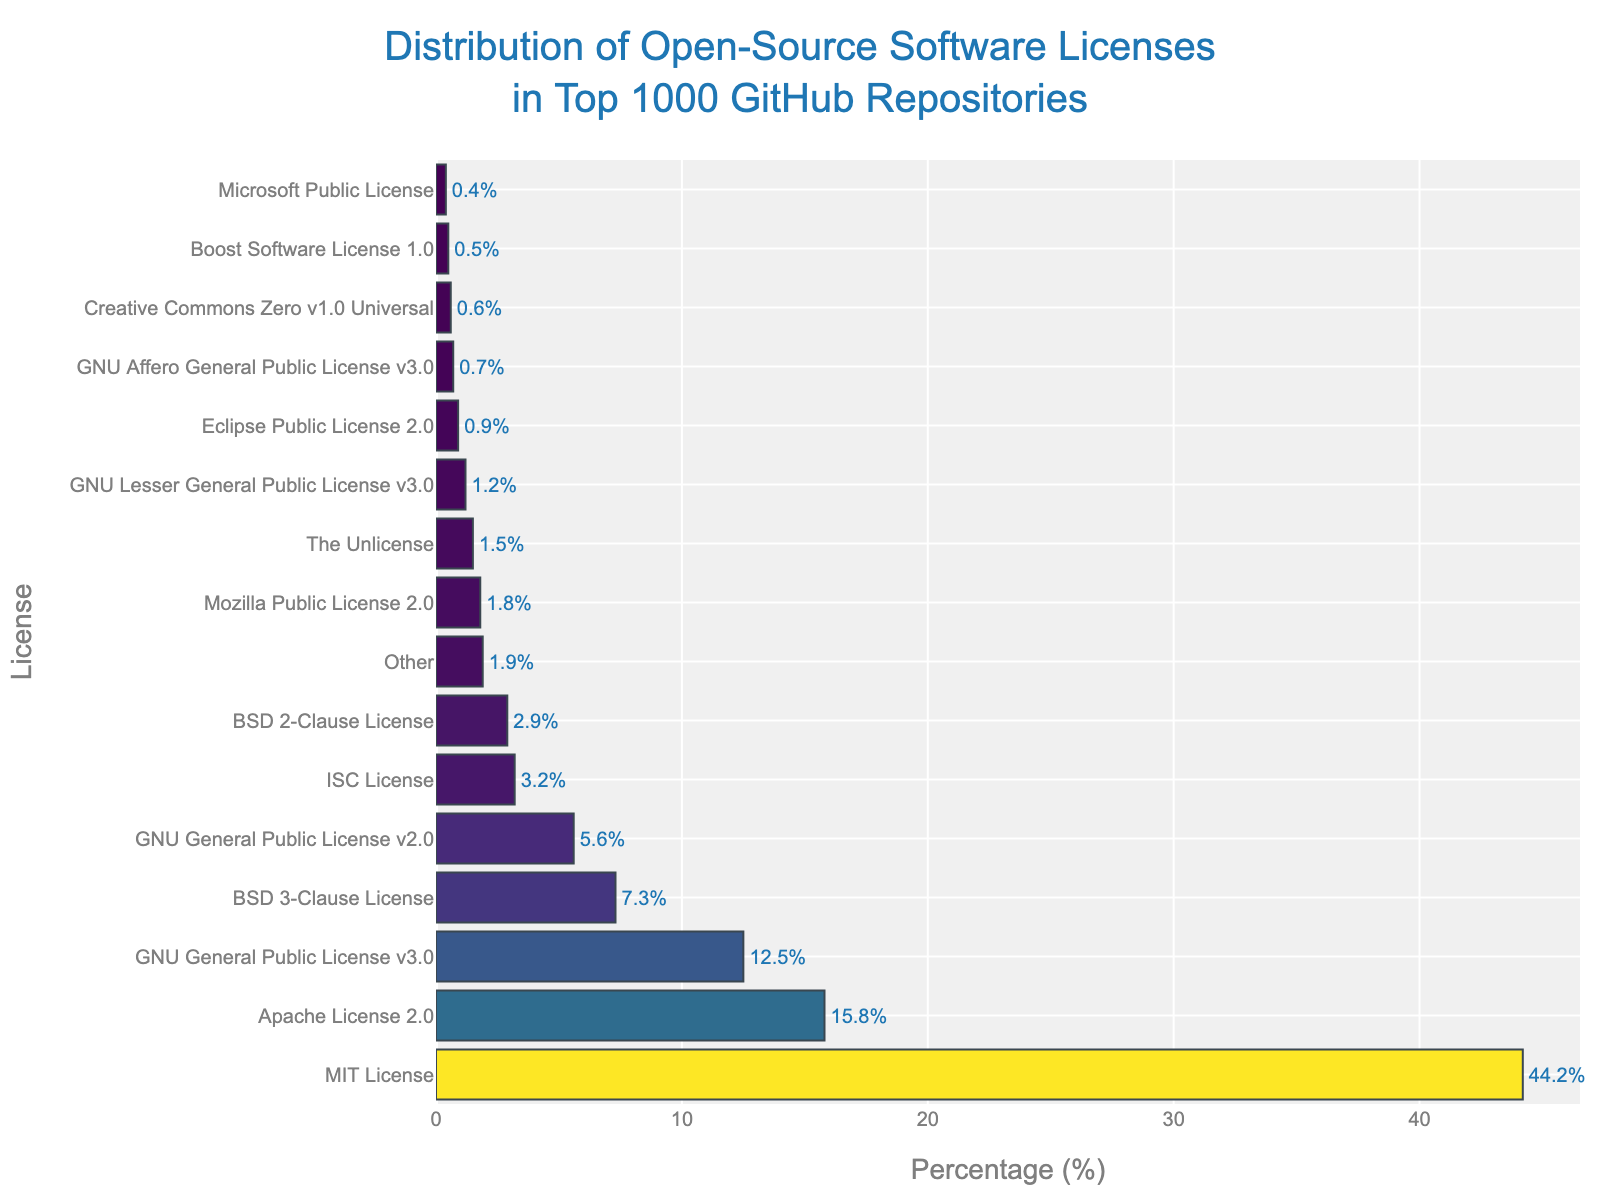What is the most commonly used license among the top 1000 GitHub repositories? The figure shows that the MIT License bar is the longest and positioned at the top, indicating it has the highest percentage at 44.2%.
Answer: MIT License How much higher is the percentage of MIT License compared to Apache License 2.0? The figure shows the MIT License at 44.2% and Apache License 2.0 at 15.8%. The difference is calculated as 44.2% - 15.8%.
Answer: 28.4% Which licenses have a usage percentage below 1%? The figure shows that the Eclipse Public License 2.0, GNU Affero General Public License v3.0, Creative Commons Zero v1.0 Universal, Boost Software License 1.0, and Microsoft Public License all have bars with percentages below 1%.
Answer: Eclipse Public License 2.0, GNU Affero General Public License v3.0, Creative Commons Zero v1.0 Universal, Boost Software License 1.0, Microsoft Public License How does the usage percentage of BSD 3-Clause License compare to GNU General Public License v2.0? The figure shows that BSD 3-Clause License has a percentage of 7.3%, while GNU General Public License v2.0 shows 5.6%. BSD 3-Clause License is higher.
Answer: BSD 3-Clause License is higher What is the combined percentage of all GNU licenses? Summing up the percentages of GNU licenses listed in the figure: GNU General Public License v3.0 (12.5%), GNU General Public License v2.0 (5.6%), GNU Lesser General Public License v3.0 (1.2%), and GNU Affero General Public License v3.0 (0.7%). Adding these yields 12.5% + 5.6% + 1.2% + 0.7%.
Answer: 20.0% What licenses are represented by bars colored with the darkest shade in the figure? The darkest shades are typically used for the lowest-value bars. The bars for the Eclipse Public License 2.0 (0.9%), GNU Affero General Public License v3.0 (0.7%), Creative Commons Zero v1.0 Universal (0.6%), Boost Software License 1.0 (0.5%), and Microsoft Public License (0.4%) show the darkest colors.
Answer: Eclipse Public License 2.0, GNU Affero General Public License v3.0, Creative Commons Zero v1.0 Universal, Boost Software License 1.0, Microsoft Public License 